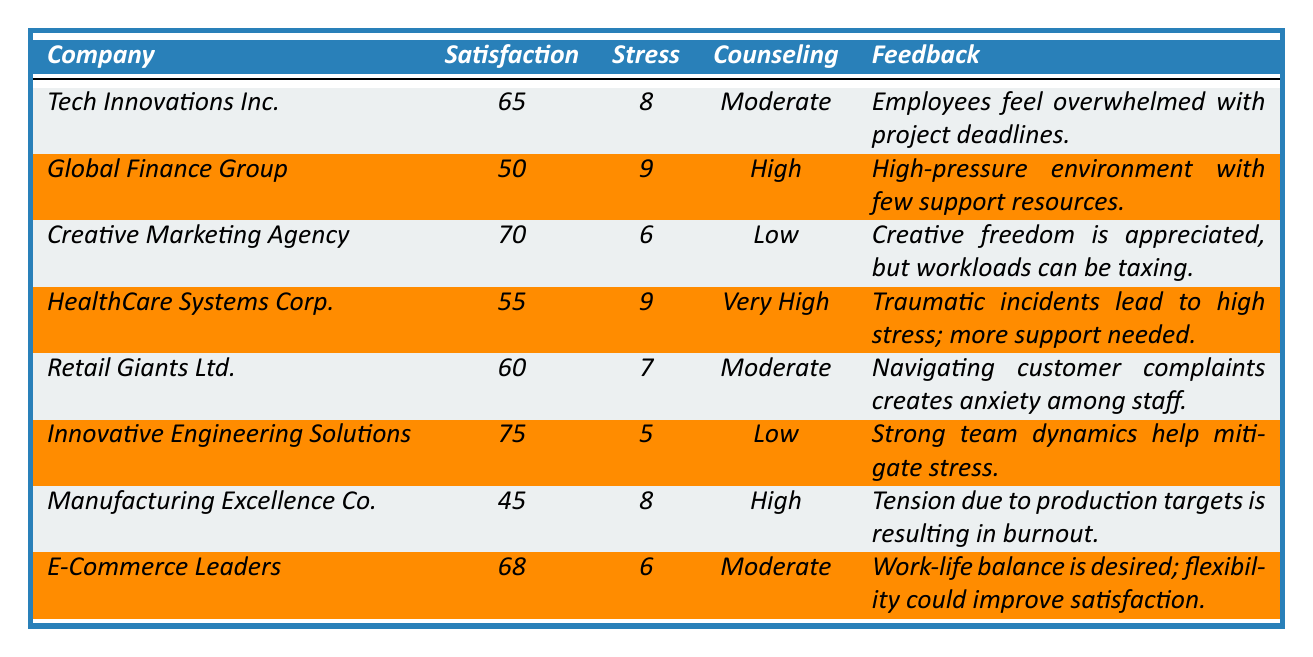What is the satisfaction score for Tech Innovations Inc.? The table indicates the satisfaction score for Tech Innovations Inc. is listed directly in the relevant row. The score is 65.
Answer: 65 Which company has the highest satisfaction score? By comparing the satisfaction scores in the table, Innovative Engineering Solutions has the highest score of 75.
Answer: Innovative Engineering Solutions What is the average stress level across all companies? To find the average stress level, add all the stress levels (8+9+6+9+7+5+8+6=58) and divide by the number of companies (8): 58/8 = 7.25.
Answer: 7.25 Is the counseling utilization level highest in HealthCare Systems Corp.? The counseling utilization level for HealthCare Systems Corp. is "Very High," which is higher than all other companies listed.
Answer: Yes How many companies report a satisfaction score below 60? From the table, Manufacturing Excellence Co. (45) and Global Finance Group (50) are the only companies with satisfaction scores below 60. Thus, there are 2 companies.
Answer: 2 What is the difference between the highest and lowest satisfaction scores? The highest satisfaction score is 75 (Innovative Engineering Solutions) and the lowest is 45 (Manufacturing Excellence Co.). The difference is 75 - 45 = 30.
Answer: 30 Which department has the highest reported stress level, and what is that level? By examining the stress levels for each department, both Global Finance Group and HealthCare Systems Corp. report a stress level of 9, which is the highest in the table.
Answer: Investment Banking and Emergency Services; 9 Does Creative Marketing Agency have a higher satisfaction score compared to Retail Giants Ltd.? Checking the satisfaction scores, Creative Marketing Agency has a score of 70 while Retail Giants Ltd. has 60. Thus, Creative Marketing Agency does indeed have a higher score.
Answer: Yes What company has a moderate level of counseling utilization but a higher satisfaction score than Tech Innovations Inc.? E-Commerce Leaders has a satisfaction score of 68, which is higher than Tech Innovations Inc.'s score of 65, and both report a counseling utilization level of Moderate.
Answer: E-Commerce Leaders Calculate the total satisfaction score of all companies combined. Adding all the satisfaction scores together gives 65 + 50 + 70 + 55 + 60 + 75 + 45 + 68 = 450.
Answer: 450 